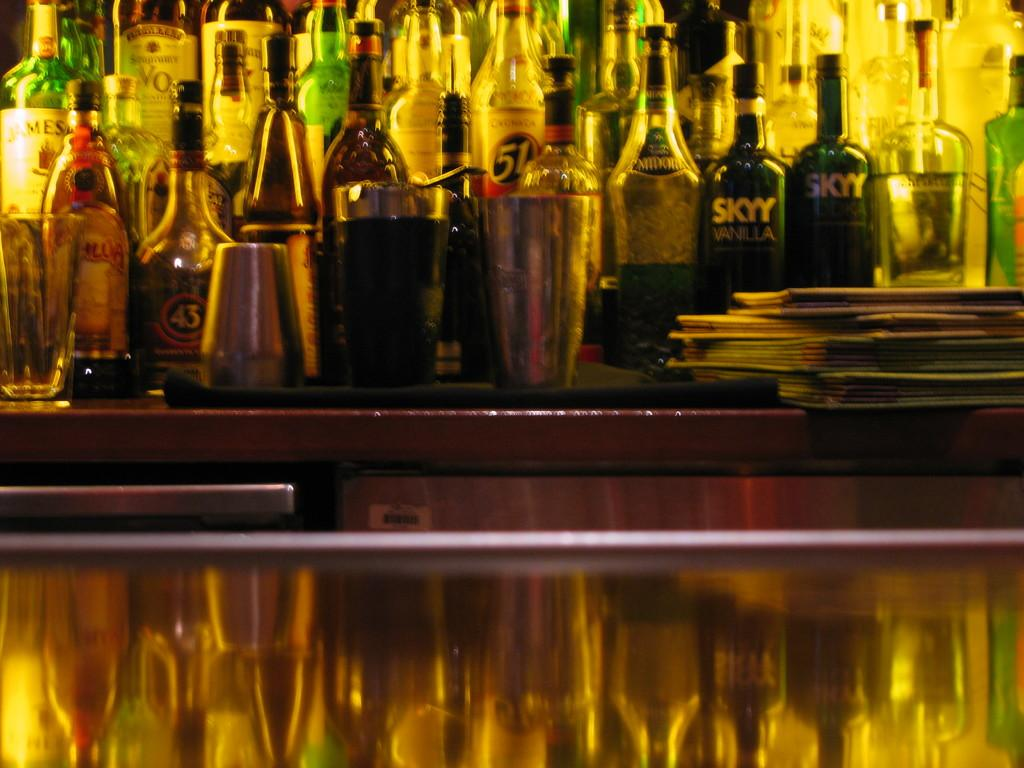Provide a one-sentence caption for the provided image. Two bottles of Skyy vodka is sitting on a shelf with several other bottles of liquor. 